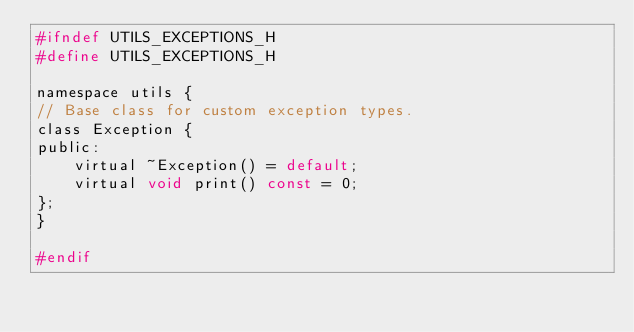<code> <loc_0><loc_0><loc_500><loc_500><_C_>#ifndef UTILS_EXCEPTIONS_H
#define UTILS_EXCEPTIONS_H

namespace utils {
// Base class for custom exception types.
class Exception {
public:
    virtual ~Exception() = default;
    virtual void print() const = 0;
};
}

#endif
</code> 